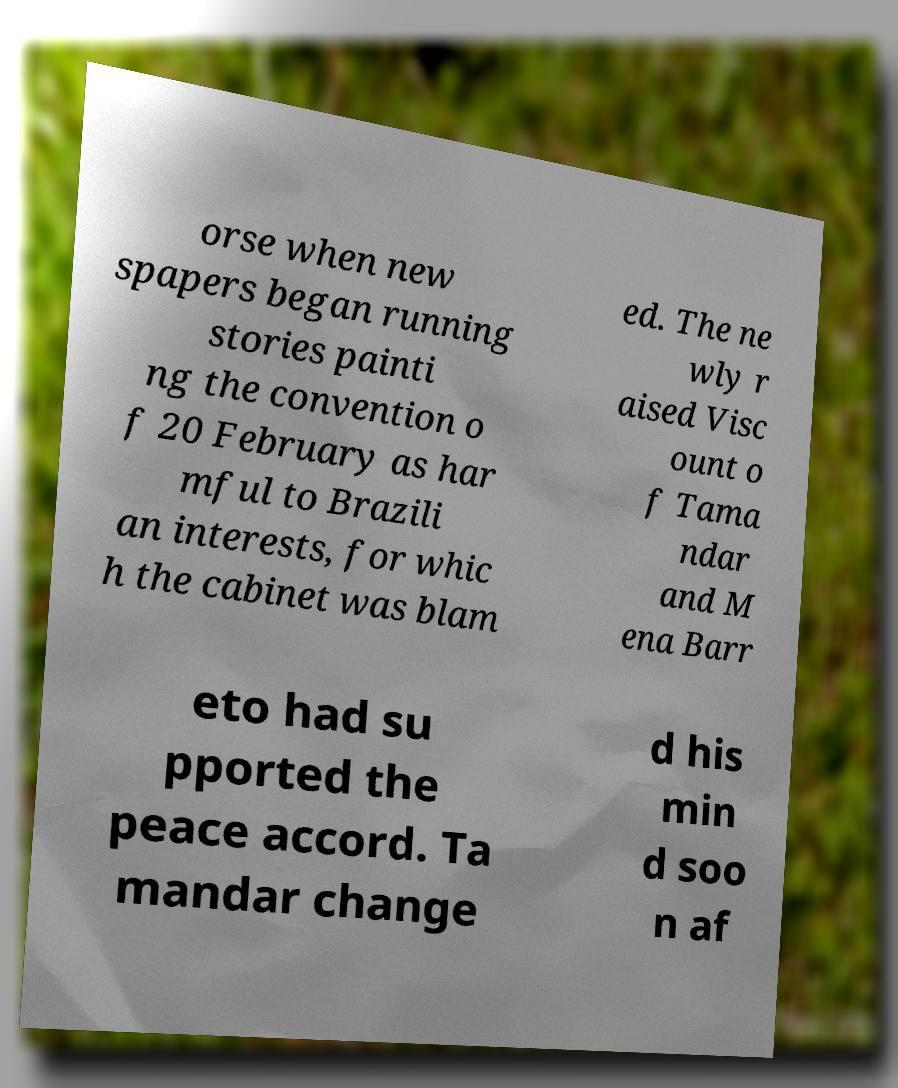Please identify and transcribe the text found in this image. orse when new spapers began running stories painti ng the convention o f 20 February as har mful to Brazili an interests, for whic h the cabinet was blam ed. The ne wly r aised Visc ount o f Tama ndar and M ena Barr eto had su pported the peace accord. Ta mandar change d his min d soo n af 